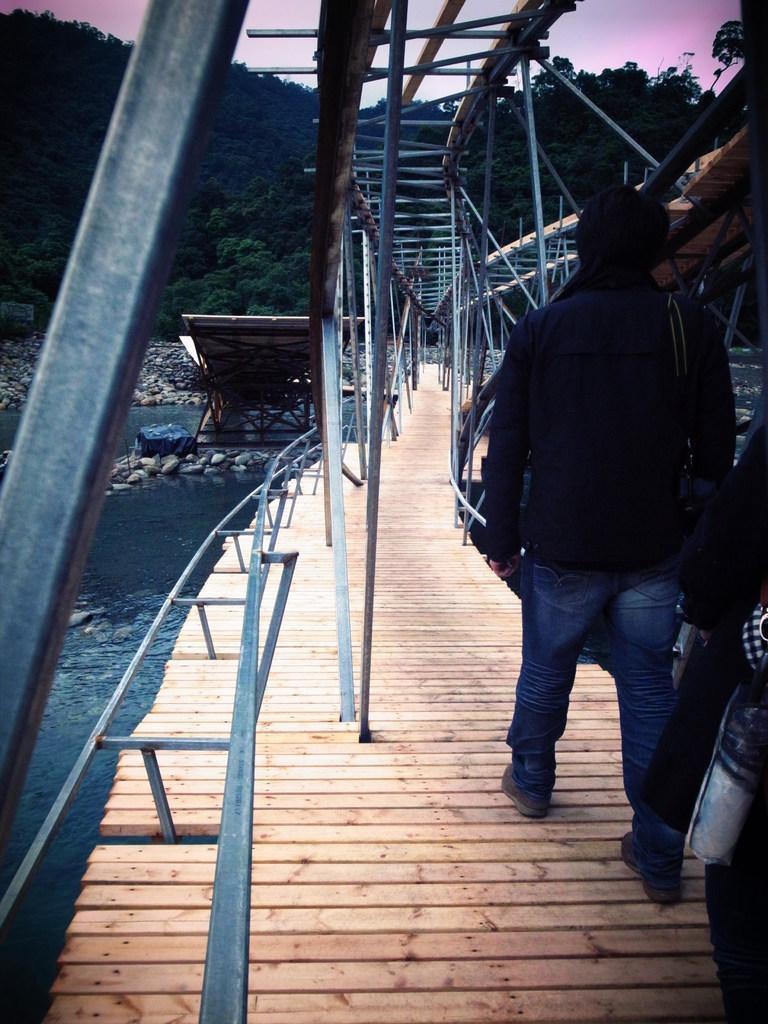Could you give a brief overview of what you see in this image? In this picture we can see two people were a person walking on a bridge, poles, stones, trees, mountains, water and some objects and in the background we can see the sky. 